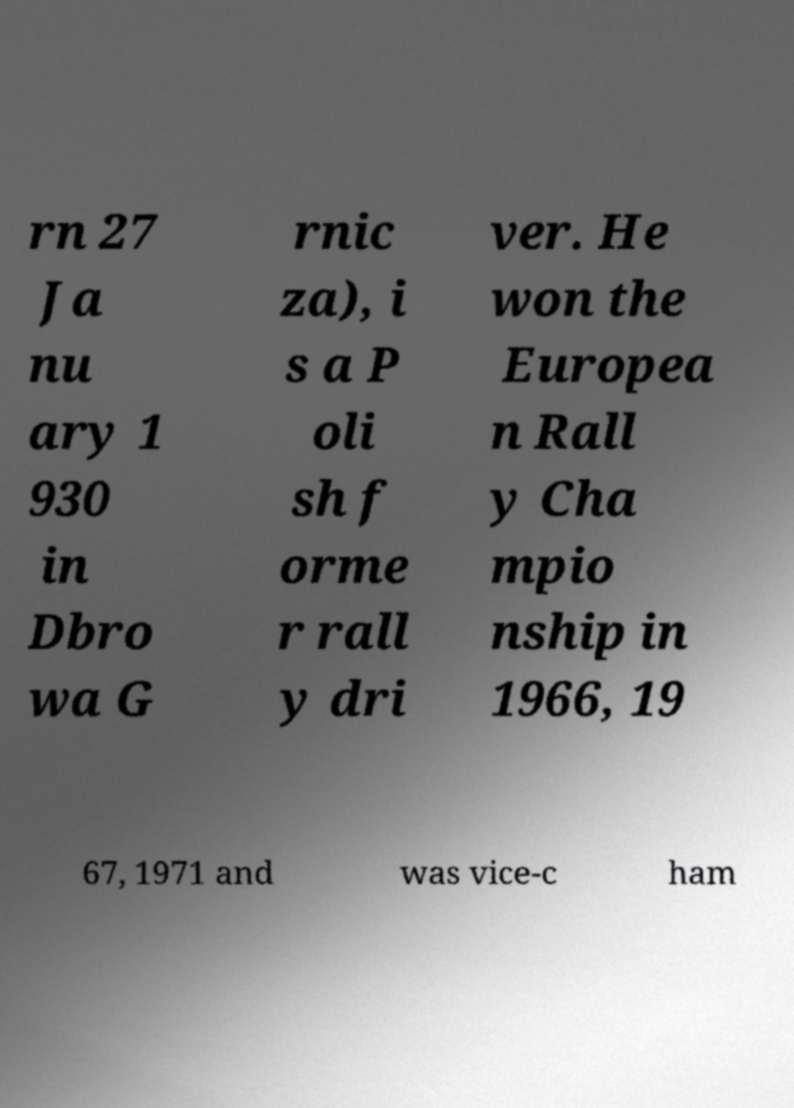I need the written content from this picture converted into text. Can you do that? rn 27 Ja nu ary 1 930 in Dbro wa G rnic za), i s a P oli sh f orme r rall y dri ver. He won the Europea n Rall y Cha mpio nship in 1966, 19 67, 1971 and was vice-c ham 